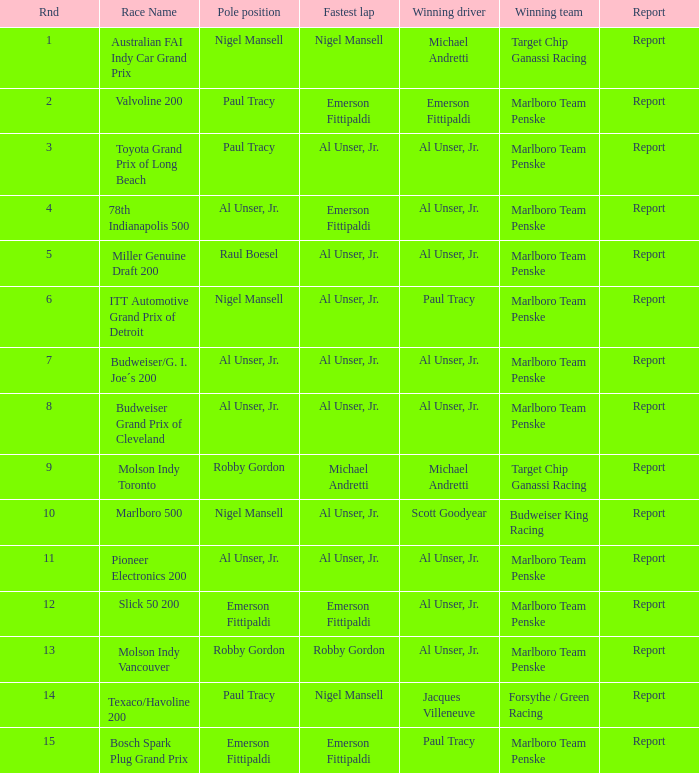Who was on the pole position in the Texaco/Havoline 200 race? Paul Tracy. 